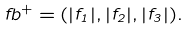Convert formula to latex. <formula><loc_0><loc_0><loc_500><loc_500>\ f b ^ { + } = ( | f _ { 1 } | , | f _ { 2 } | , | f _ { 3 } | ) .</formula> 